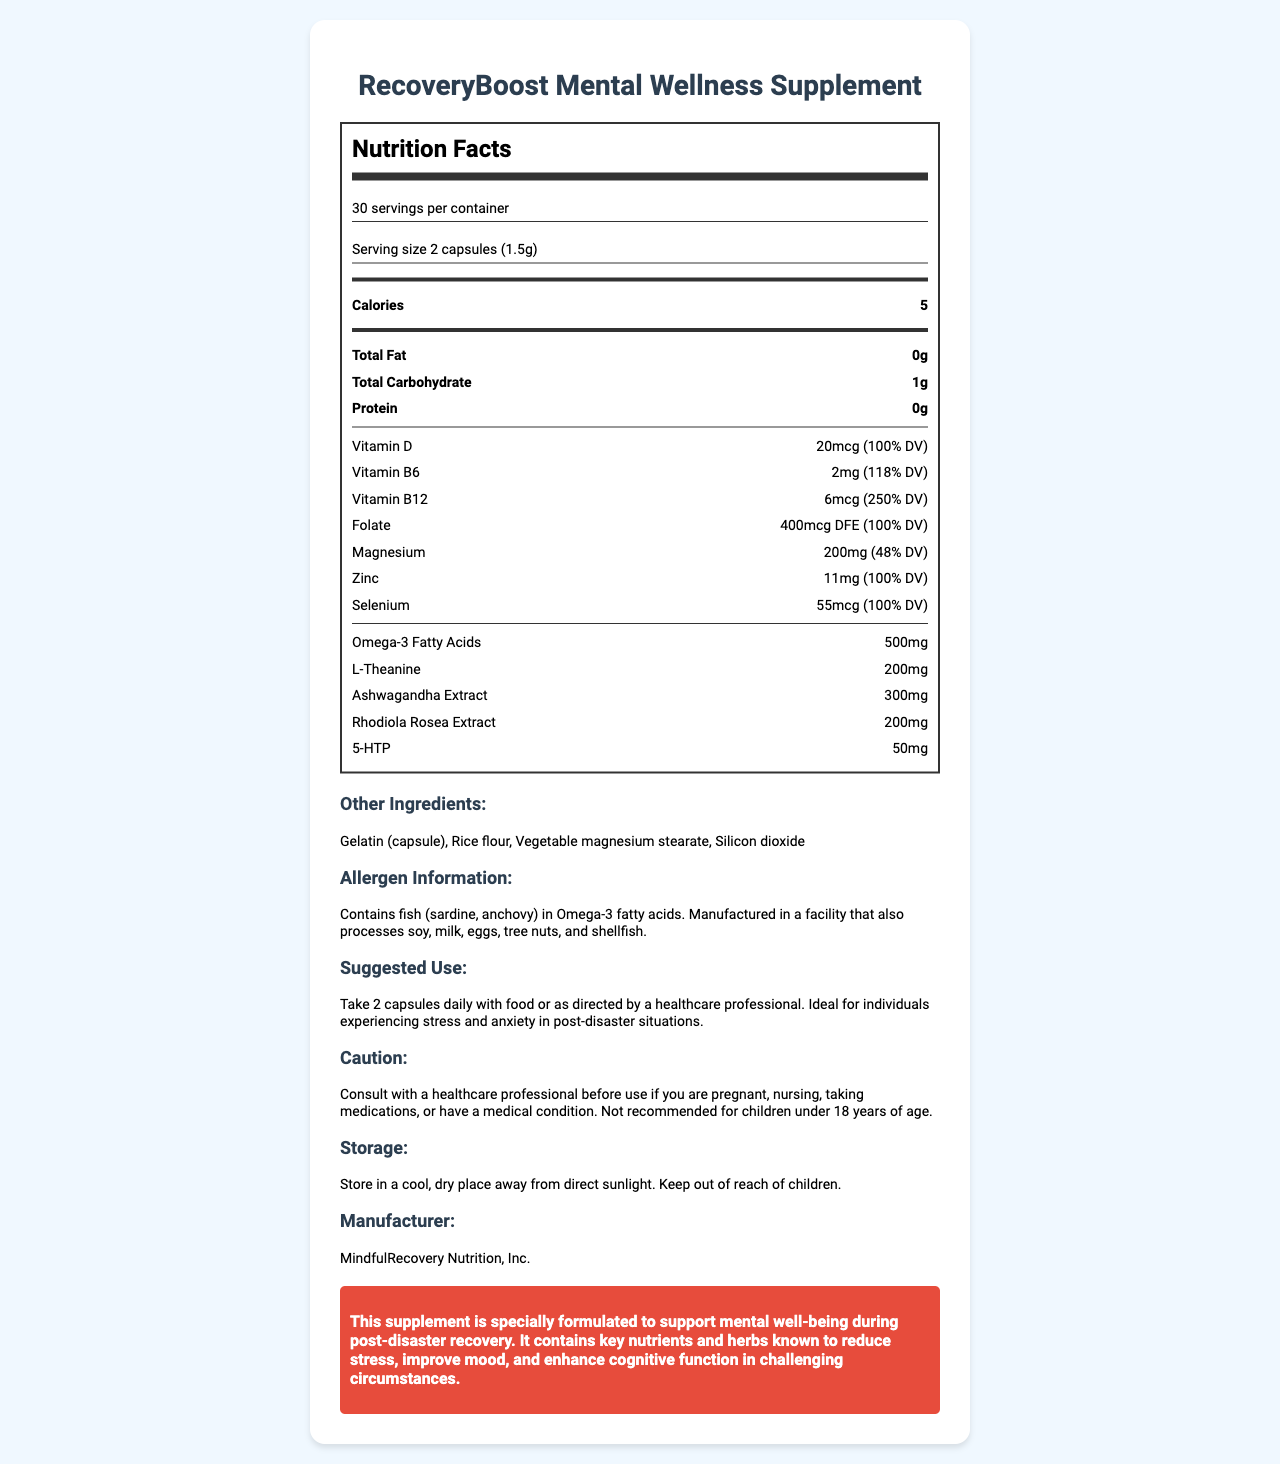what is the serving size? The serving size is listed at the beginning of the Nutrition Facts section.
Answer: 2 capsules (1.5g) how many servings are in one container? This information is found right under the product name and serving size.
Answer: 30 servings what is one nutrient that provides 250% of the Daily Value? Vitamin B12 provides 250% DV, as stated in the nutrients list.
Answer: Vitamin B12 what are the total carbohydrates per serving? The total carbohydrates are listed as 1g in the main nutrient section.
Answer: 1g which mineral is present at 48% of the Daily Value? Magnesium is listed with 200mg, which equates to 48% of the Daily Value.
Answer: Magnesium how much Omega-3 fatty acids are in each serving? The amount of Omega-3 fatty acids is listed as 500mg.
Answer: 500mg which vitamin is present at 100% of the Daily Value? A. Vitamin C B. Vitamin D C. Vitamin E Vitamin D is present at 20mcg, which is 100% of the Daily Value.
Answer: B what special ingredient is included for reducing stress? A. L-Theanine B. Ashwagandha Extract C. Rhodiola Rosea Extract D. All of the above All three (L-Theanine, Ashwagandha Extract, Rhodiola Rosea Extract) are listed and known for reducing stress.
Answer: D does this supplement contain any fish ingredients? The allergen information notes that it contains fish (sardine, anchovy) in Omega-3 fatty acids.
Answer: Yes what is the main purpose of the RecoveryBoost Mental Wellness Supplement? The disaster-specific info section states the main purpose is to support mental well-being during post-disaster recovery.
Answer: Support mental well-being during post-disaster recovery describe the main points of the document. This document focuses on the nutritional profile and specialized mental health benefits of the RecoveryBoost Mental Wellness Supplement in post-disaster recovery scenarios.
Answer: The document provides detailed nutritional information for the RecoveryBoost Mental Wellness Supplement, tailored for post-disaster recovery. It lists servings, calories, macronutrients, and micronutrients, emphasizing vitamins and minerals essential for mental health. Additionally, it includes special ingredients for stress reduction and provides usage instructions, allergen info, and storage conditions. how does this supplement need to be stored? The storage instructions detail keeping the product in a cool, dry place and out of children's reach.
Answer: In a cool, dry place away from direct sunlight. Keep out of reach of children. what is one ingredient in this supplement's capsule? Gelatin is listed as one of the ingredients in the capsule.
Answer: Gelatin can this supplement be taken by children under 18 years of age? The caution section clearly states it is not recommended for children under 18 years of age.
Answer: No where is this supplement manufactured? The manufacturer section lists MindfulRecovery Nutrition, Inc. as the producer.
Answer: MindfulRecovery Nutrition, Inc. how should individuals experiencing stress and anxiety in post-disaster situations take this supplement? The suggested use section mentions this dosage specifically for individuals experiencing stress and anxiety in post-disaster situations.
Answer: Take 2 capsules daily with food or as directed by a healthcare professional is the document sufficient to understand the clinical efficacy of the supplement? The document provides nutritional information but does not include clinical trial data or efficacy studies.
Answer: Not enough information what is the highest Daily Value percentage for a nutrient listed? The highest DV percentage listed is for Vitamin B12, which is 250%.
Answer: 250% (Vitamin B12) 